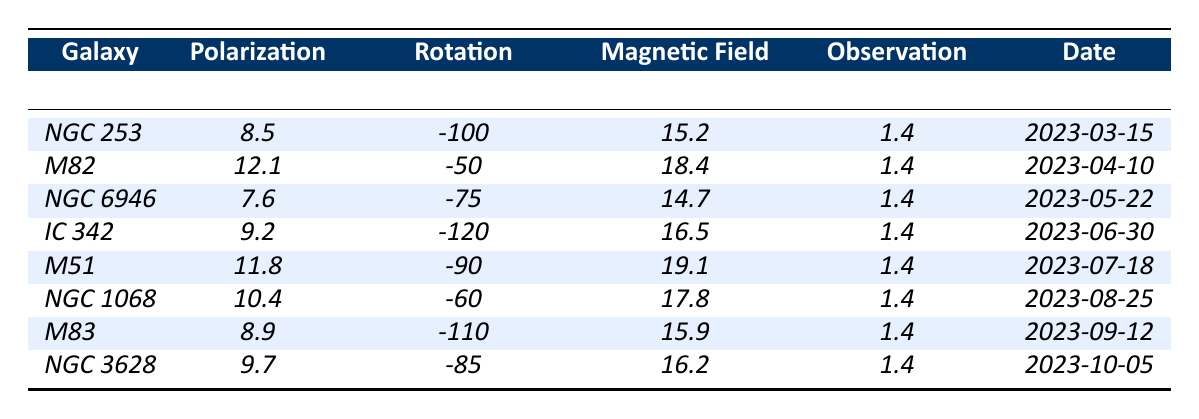What is the polarization fraction for M82? The table shows the row for M82, and in the column for Polarization Fraction, the value listed is 12.1%.
Answer: 12.1% Which galaxy has the highest magnetic field strength? By comparing the values in the Magnetic Field Strength column, M51 has the highest value at 19.1 μG.
Answer: M51 What is the rotation measure for NGC 6936? The table does not include NGC 6936; hence, we cannot find a rotation measure for it, which means the statement is false.
Answer: No What is the average polarization fraction for all the listed galaxies? First, we sum the polarization fractions: (8.5 + 12.1 + 7.6 + 9.2 + 11.8 + 10.4 + 8.9 + 9.7) = 78.2. There are 8 galaxies, so we calculate the average as 78.2 / 8 = 9.775%.
Answer: 9.775% Which galaxy was observed last? The table lists the dates for observation, with NGC 3628 observed on 2023-10-05, making it the most recent observation.
Answer: NGC 3628 Do any galaxies have the same polarization fraction? By checking each polarization fraction value in the table, all values are unique, indicating that no two galaxies have the same polarization fraction.
Answer: No What is the difference in magnetic field strength between M82 and NGC 253? M82 has a magnetic field strength of 18.4 μG, while NGC 253's is 15.2 μG. The difference is 18.4 - 15.2 = 3.2 μG.
Answer: 3.2 μG Is there a correlation between polarization fraction and magnetic field strength? To analyze correlation, we would look at changes in both values across galaxies; while exploration is needed for a definitive answer, patterns should be examined in the values provided.
Answer: Needs analysis What is the total of all rotation measures in the table? Summing the rotation measures: (-100 + -50 + -75 + -120 + -90 + -60 + -110 + -85) results in a total of -790.
Answer: -790 Which galaxy has the lowest polarization fraction? The polarization fraction for NGC 6946 is the lowest at 7.6%.
Answer: NGC 6946 